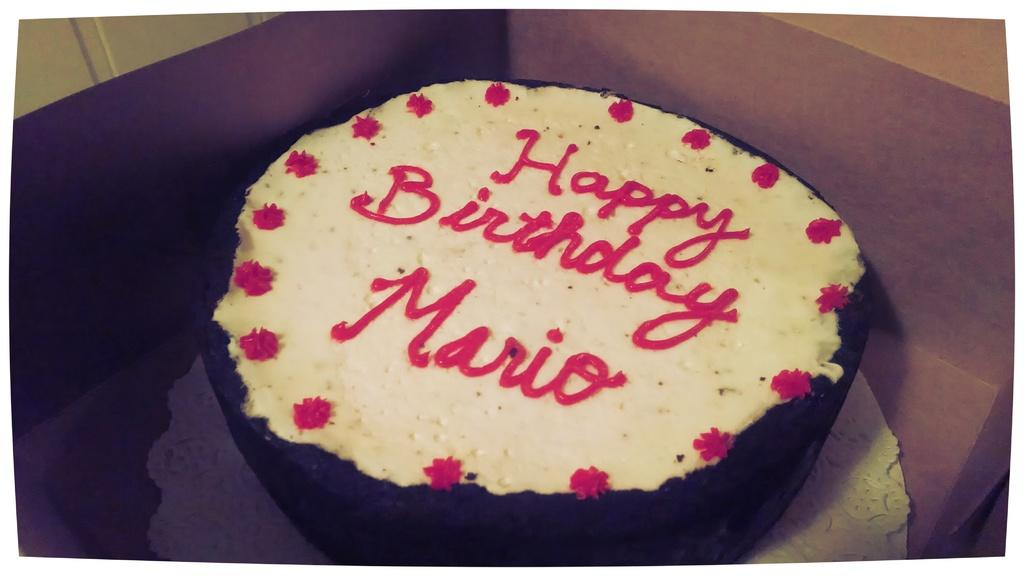What is inside the pastry box in the image? The pastry box contains a cake. What message is written on the cake? The cake has "Happy Birthday Mario" written on it. What can be seen in the top left corner of the image? There is a wall visible in the top left of the image. What type of ink is used to write the message on the cake? There is no information about the type of ink used to write the message on the cake, as it is not mentioned in the facts provided. 